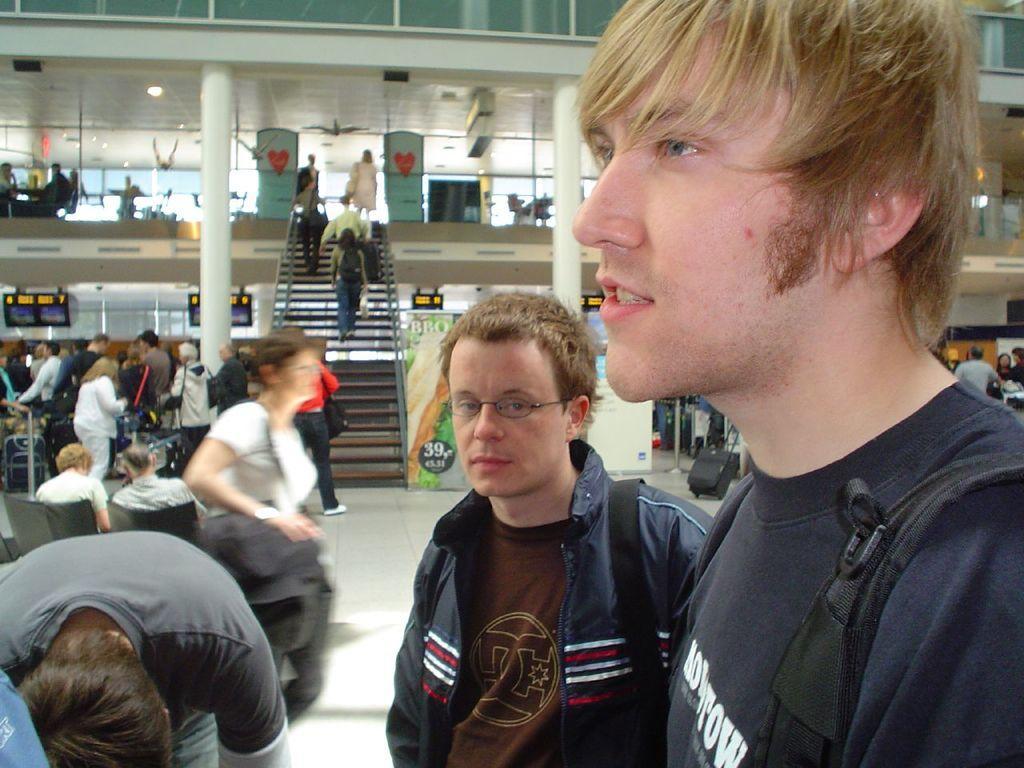In one or two sentences, can you explain what this image depicts? This picture shows a building and we see few people standing and few are seated on the chairs and we see couple of men wore backpack on their back and we see a woman wore a bag and we see stairs, few people climbing and we see lights on the roof and we see a advertisement hoarding. 